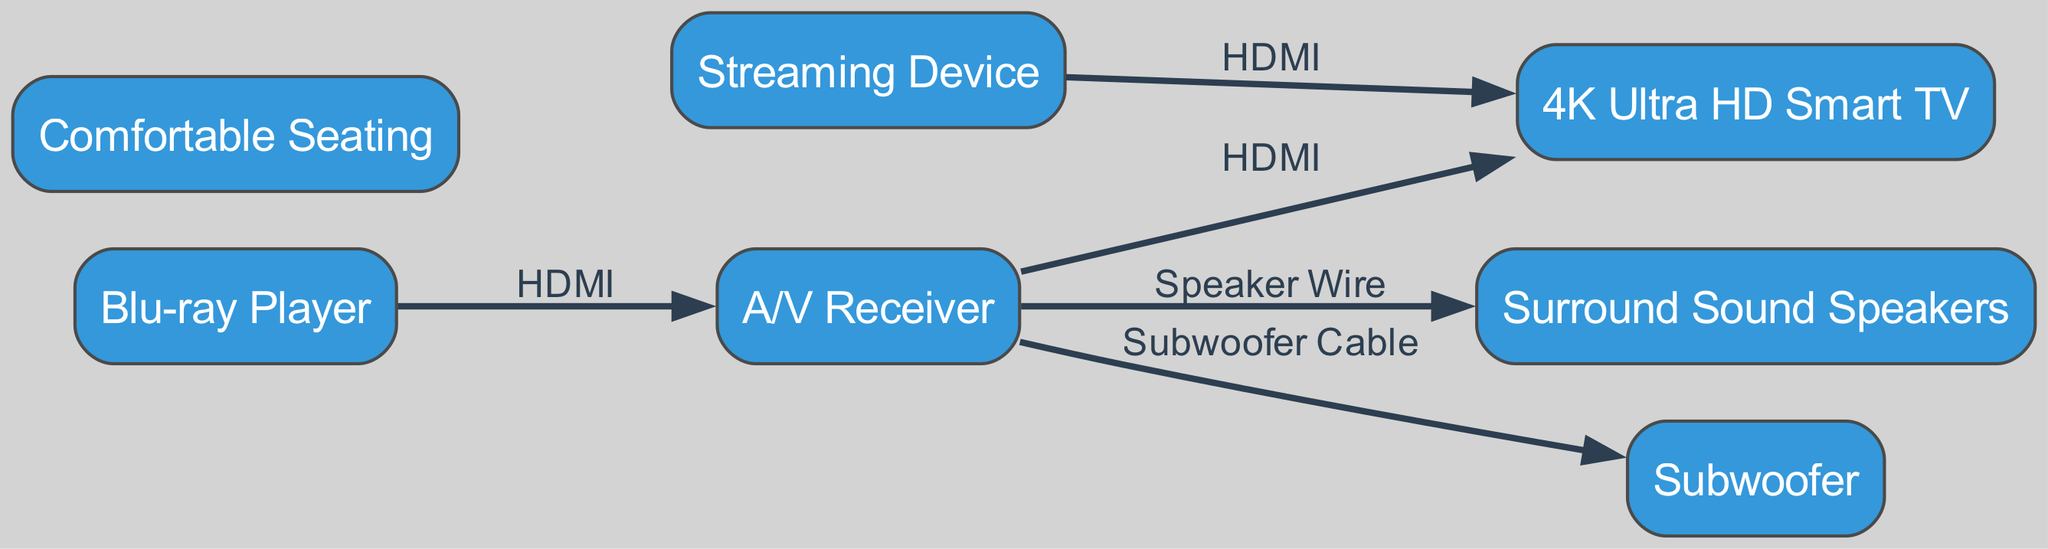What is the main display component in the setup? The main display component listed in the diagram is the "4K Ultra HD Smart TV," which is the only node explicitly labeled as a display device.
Answer: 4K Ultra HD Smart TV How many components are connected to the A/V Receiver? The A/V Receiver is connected to three components: the Blu-ray Player, Surround Sound Speakers, and the 4K Ultra HD Smart TV. Counting them indicates that there are three connections indicated by edges stemming from A/V Receiver.
Answer: 3 What type of cable connects the Streaming Device to the Smart TV? The diagram shows that the Streaming Device connects to the Smart TV using an HDMI cable, as indicated by the label on the edge connecting them.
Answer: HDMI Which component does the Subwoofer connect to? The Subwoofer connects to the A/V Receiver, as shown by the edge with the specified connection labeled as a Subwoofer Cable.
Answer: A/V Receiver What is the function of the Surround Sound Speakers in the setup? The function of the Surround Sound Speakers in this home theater setup is to deliver audio output, enhancing the quality of documentary sound. They are directly connected to the A/V Receiver, indicating their role in audio playback.
Answer: Audio output How many nodes represent audio components in the diagram? The diagram shows two audio components: the Surround Sound Speakers and the Subwoofer, confirming that there are two nodes specifically designed for audio output in this setup.
Answer: 2 What is the role of Comfortable Seating in the diagram? The Comfortable Seating is listed in the diagram as a component that enhances the viewing experience, although it does not have any direct connection with other components, it indicates an aspect of user experience in the setup.
Answer: User experience Which device connects to the A/V Receiver via HDMI? The device that connects to the A/V Receiver via HDMI is the Blu-ray Player, as represented by the edge labeled with HDMI connecting the two nodes.
Answer: Blu-ray Player What is the relationship between the Blu-ray Player and the A/V Receiver? The relationship between the Blu-ray Player and the A/V Receiver is that they are connected by an HDMI cable, indicating that the A/V Receiver is receiving data from the Blu-ray Player for output through the audio system and display.
Answer: HDMI connection 